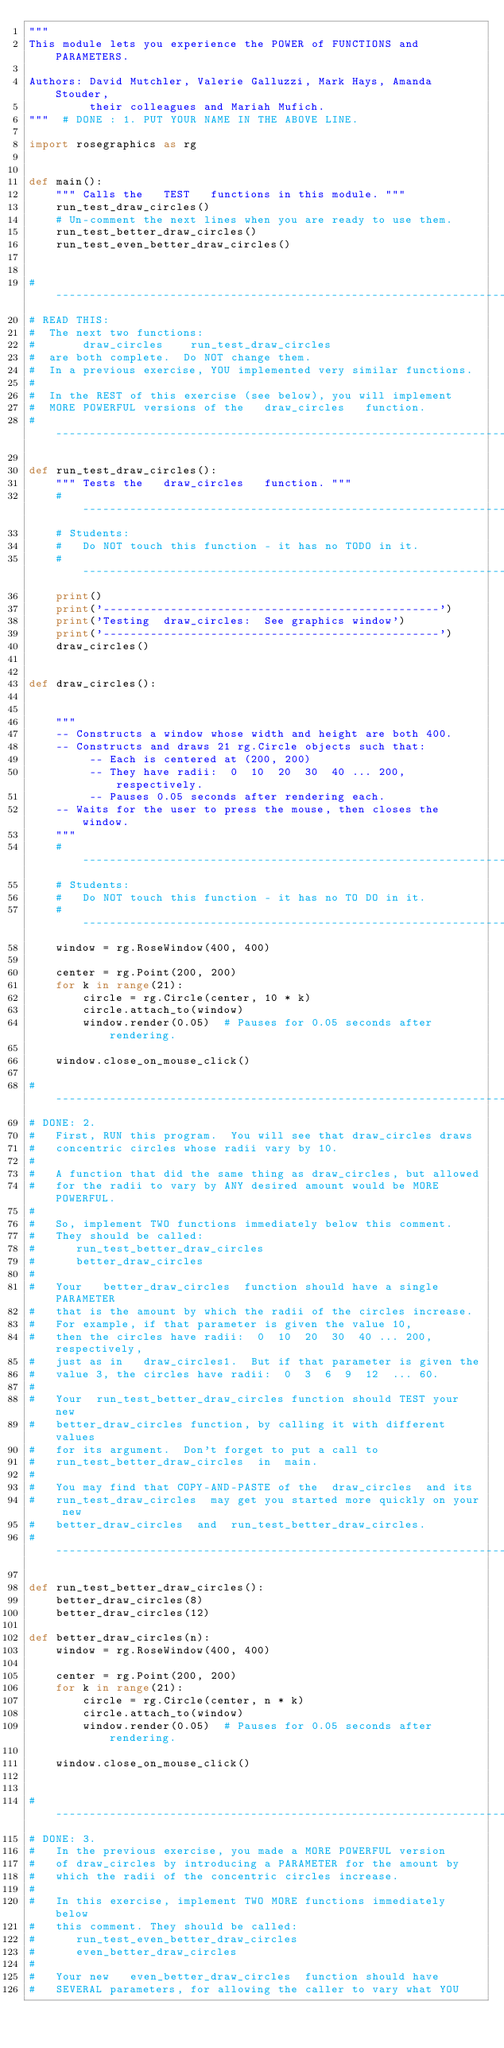Convert code to text. <code><loc_0><loc_0><loc_500><loc_500><_Python_>"""
This module lets you experience the POWER of FUNCTIONS and PARAMETERS.

Authors: David Mutchler, Valerie Galluzzi, Mark Hays, Amanda Stouder,
         their colleagues and Mariah Mufich.
"""  # DONE : 1. PUT YOUR NAME IN THE ABOVE LINE.

import rosegraphics as rg


def main():
    """ Calls the   TEST   functions in this module. """
    run_test_draw_circles()
    # Un-comment the next lines when you are ready to use them.
    run_test_better_draw_circles()
    run_test_even_better_draw_circles()


# ----------------------------------------------------------------------
# READ THIS:
#  The next two functions:
#       draw_circles    run_test_draw_circles
#  are both complete.  Do NOT change them.
#  In a previous exercise, YOU implemented very similar functions.
#
#  In the REST of this exercise (see below), you will implement
#  MORE POWERFUL versions of the   draw_circles   function.
# ----------------------------------------------------------------------

def run_test_draw_circles():
    """ Tests the   draw_circles   function. """
    # ------------------------------------------------------------------
    # Students:
    #   Do NOT touch this function - it has no TODO in it.
    # ------------------------------------------------------------------
    print()
    print('--------------------------------------------------')
    print('Testing  draw_circles:  See graphics window')
    print('--------------------------------------------------')
    draw_circles()


def draw_circles():


    """
    -- Constructs a window whose width and height are both 400.
    -- Constructs and draws 21 rg.Circle objects such that:
         -- Each is centered at (200, 200)
         -- They have radii:  0  10  20  30  40 ... 200, respectively.
         -- Pauses 0.05 seconds after rendering each.
    -- Waits for the user to press the mouse, then closes the window.
    """
    # ------------------------------------------------------------------
    # Students:
    #   Do NOT touch this function - it has no TO DO in it.
    # ------------------------------------------------------------------
    window = rg.RoseWindow(400, 400)

    center = rg.Point(200, 200)
    for k in range(21):
        circle = rg.Circle(center, 10 * k)
        circle.attach_to(window)
        window.render(0.05)  # Pauses for 0.05 seconds after rendering.

    window.close_on_mouse_click()

# ----------------------------------------------------------------------
# DONE: 2.
#   First, RUN this program.  You will see that draw_circles draws
#   concentric circles whose radii vary by 10.
#
#   A function that did the same thing as draw_circles, but allowed
#   for the radii to vary by ANY desired amount would be MORE POWERFUL.
#
#   So, implement TWO functions immediately below this comment.
#   They should be called:
#      run_test_better_draw_circles
#      better_draw_circles
#
#   Your   better_draw_circles  function should have a single PARAMETER
#   that is the amount by which the radii of the circles increase.
#   For example, if that parameter is given the value 10,
#   then the circles have radii:  0  10  20  30  40 ... 200, respectively,
#   just as in   draw_circles1.  But if that parameter is given the
#   value 3, the circles have radii:  0  3  6  9  12  ... 60.
#
#   Your  run_test_better_draw_circles function should TEST your new
#   better_draw_circles function, by calling it with different values
#   for its argument.  Don't forget to put a call to
#   run_test_better_draw_circles  in  main.
#
#   You may find that COPY-AND-PASTE of the  draw_circles  and its
#   run_test_draw_circles  may get you started more quickly on your new
#   better_draw_circles  and  run_test_better_draw_circles.
# ----------------------------------------------------------------------

def run_test_better_draw_circles():
    better_draw_circles(8)
    better_draw_circles(12)

def better_draw_circles(n):
    window = rg.RoseWindow(400, 400)

    center = rg.Point(200, 200)
    for k in range(21):
        circle = rg.Circle(center, n * k)
        circle.attach_to(window)
        window.render(0.05)  # Pauses for 0.05 seconds after rendering.

    window.close_on_mouse_click()


# ----------------------------------------------------------------------
# DONE: 3.
#   In the previous exercise, you made a MORE POWERFUL version
#   of draw_circles by introducing a PARAMETER for the amount by
#   which the radii of the concentric circles increase.
#
#   In this exercise, implement TWO MORE functions immediately below
#   this comment. They should be called:
#      run_test_even_better_draw_circles
#      even_better_draw_circles
#
#   Your new   even_better_draw_circles  function should have
#   SEVERAL parameters, for allowing the caller to vary what YOU</code> 